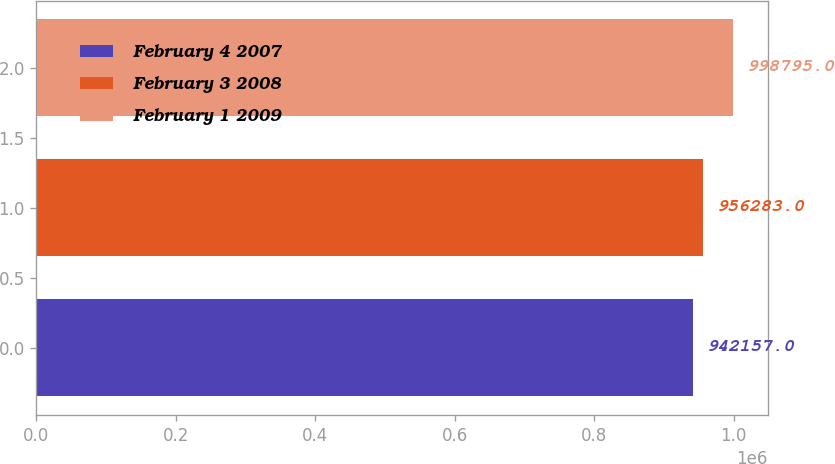Convert chart. <chart><loc_0><loc_0><loc_500><loc_500><bar_chart><fcel>February 4 2007<fcel>February 3 2008<fcel>February 1 2009<nl><fcel>942157<fcel>956283<fcel>998795<nl></chart> 